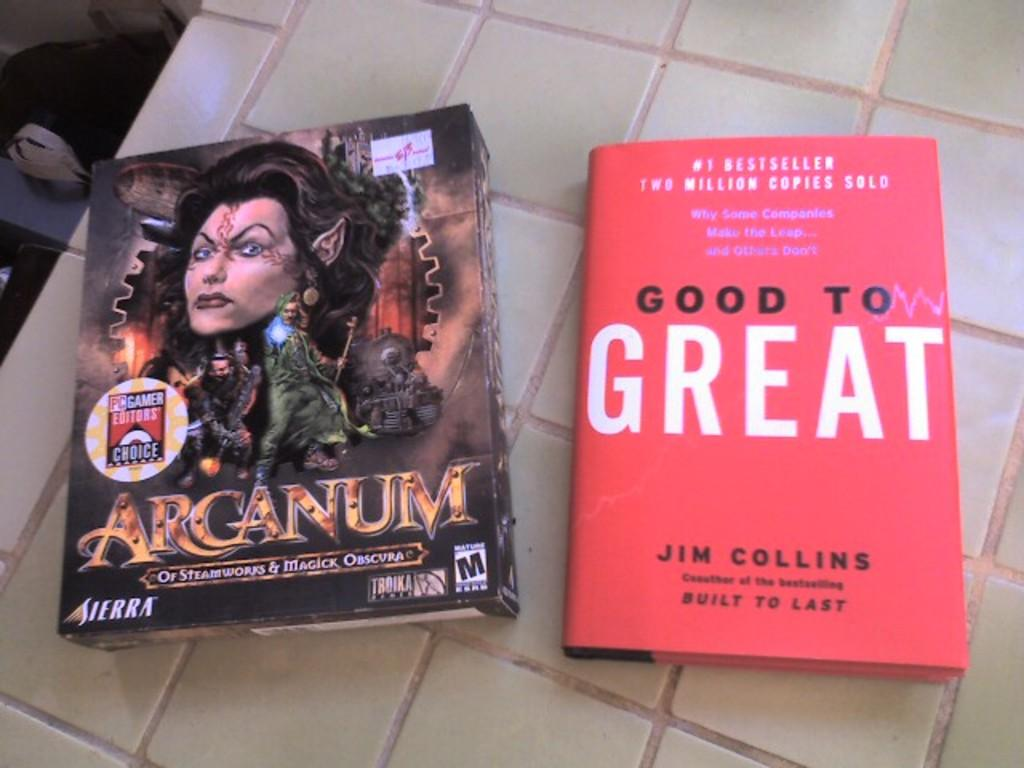<image>
Render a clear and concise summary of the photo. A book with a red cover was written by Jim Collins. 